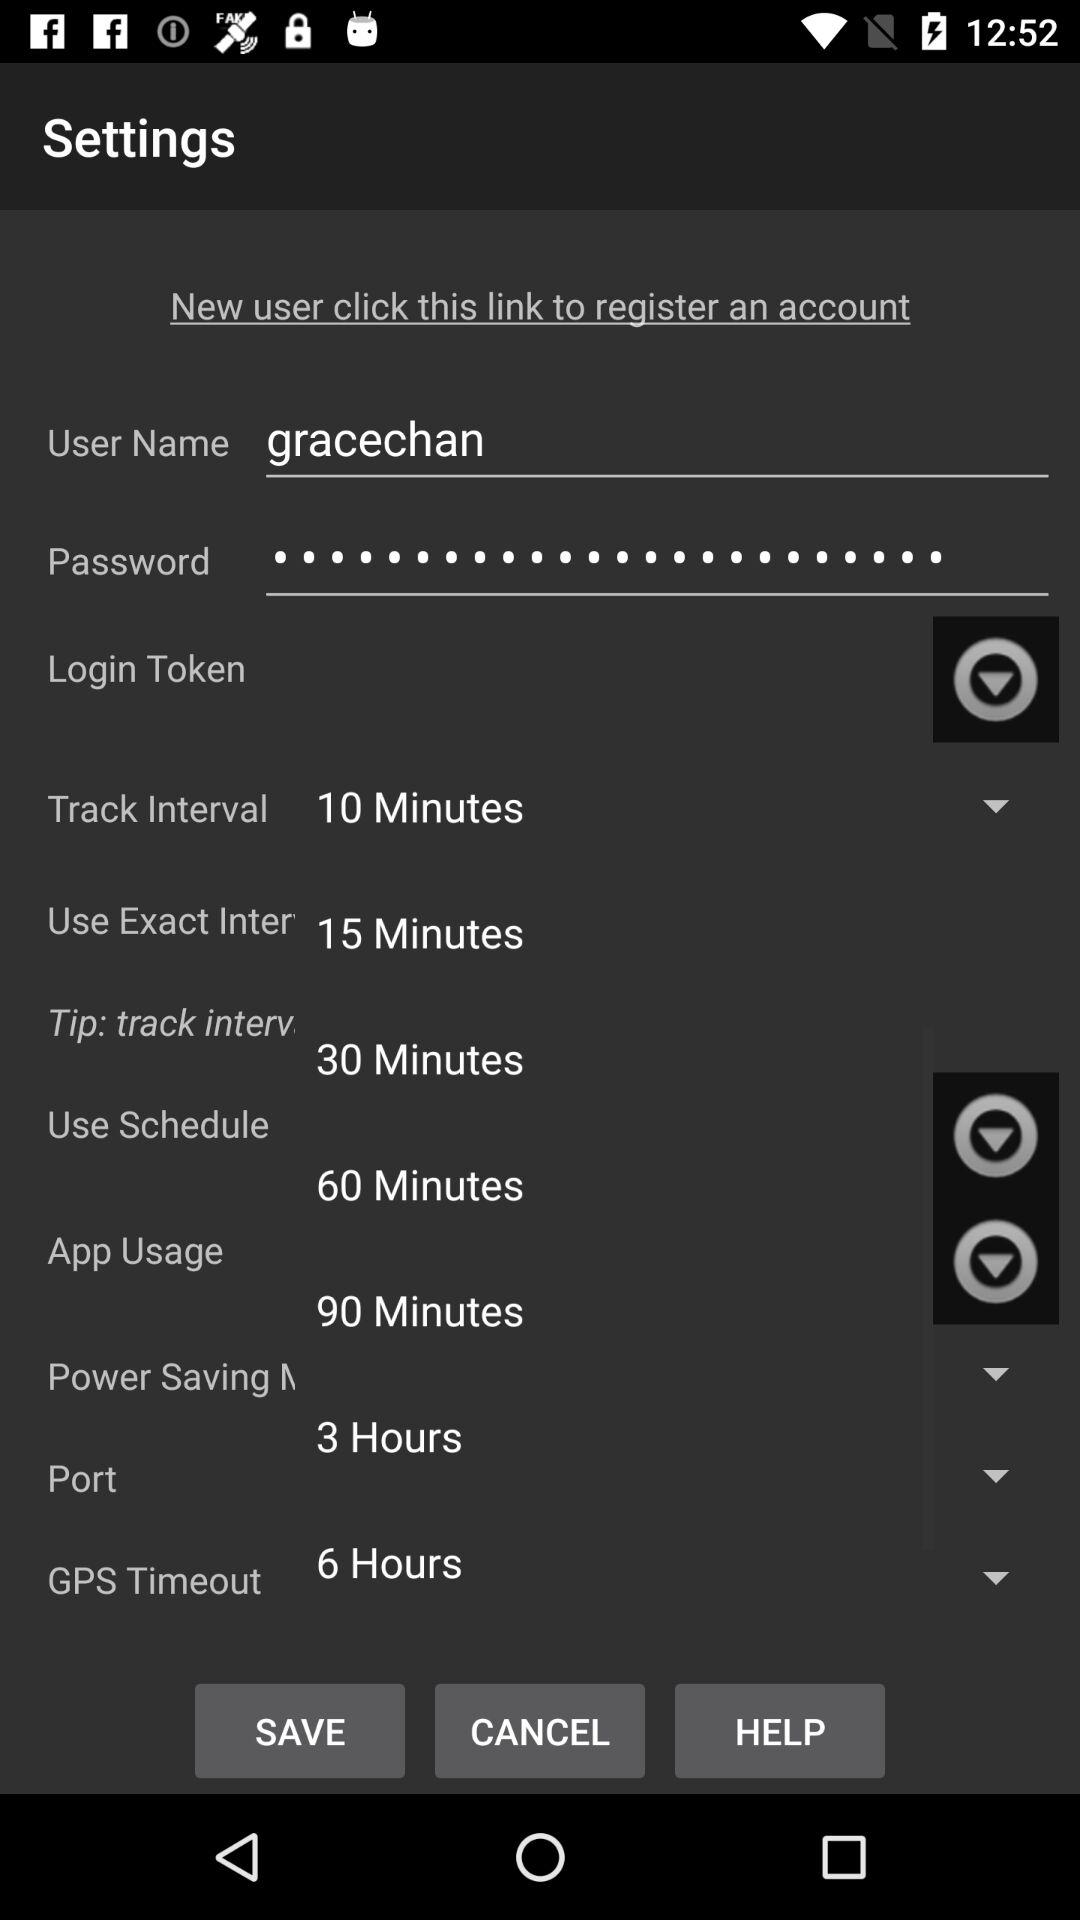What is the current state of port?
When the provided information is insufficient, respond with <no answer>. <no answer> 